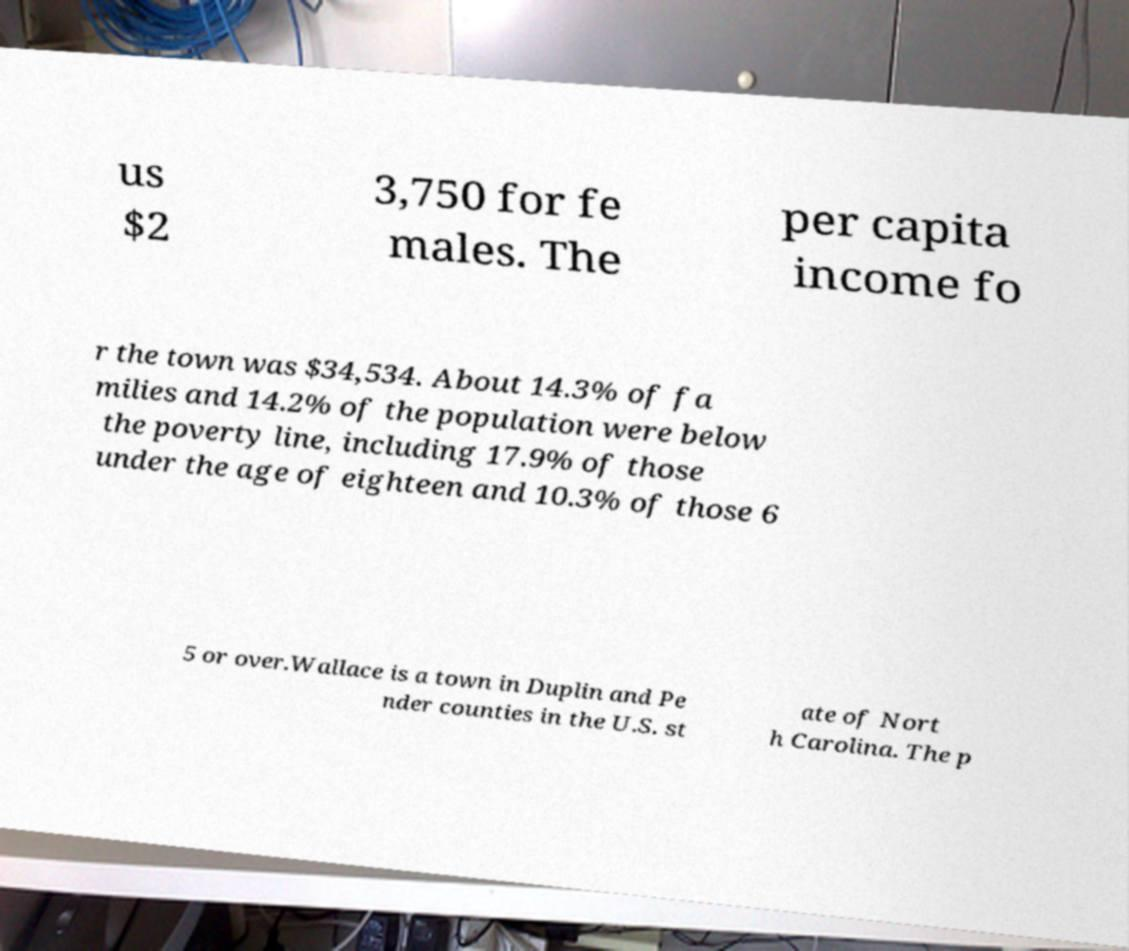Please identify and transcribe the text found in this image. us $2 3,750 for fe males. The per capita income fo r the town was $34,534. About 14.3% of fa milies and 14.2% of the population were below the poverty line, including 17.9% of those under the age of eighteen and 10.3% of those 6 5 or over.Wallace is a town in Duplin and Pe nder counties in the U.S. st ate of Nort h Carolina. The p 